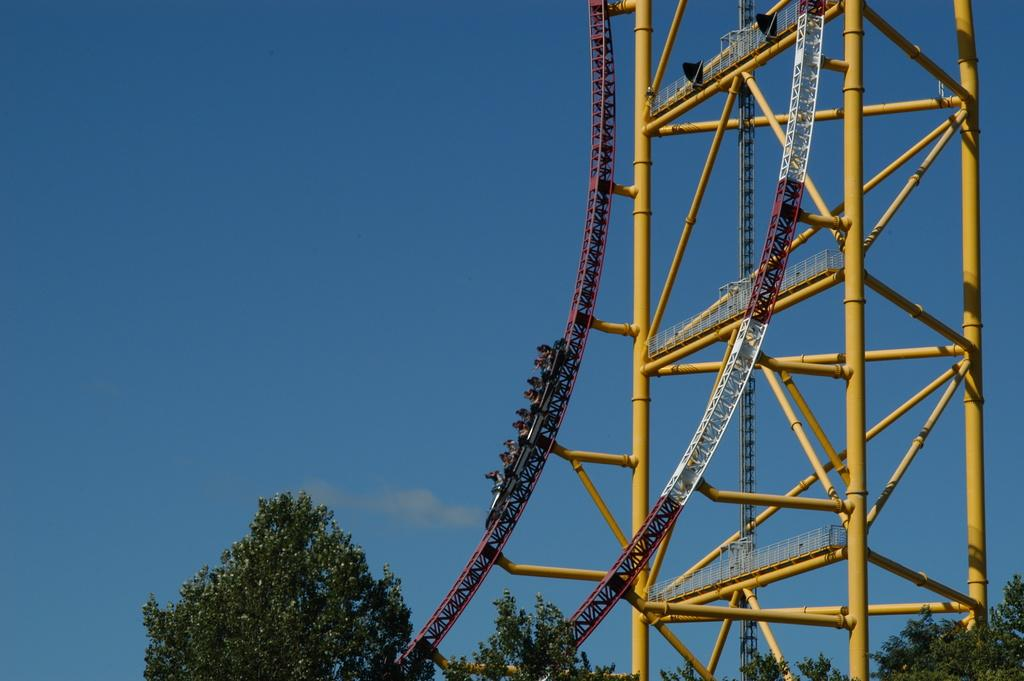What is the main subject of the image? The main subject of the image is a roller coaster. Are there any people in the image? Yes, there are persons in the image. What type of natural environment is visible at the bottom of the image? Trees are visible at the bottom of the image. What can be seen in the background of the image? The sky is visible in the background of the image. How many visitors are waiting in line for the cent in the image? There is no mention of a cent or visitors waiting in line in the image; it features a roller coaster and people. What type of parcel is being delivered to the roller coaster in the image? There is no parcel or delivery mentioned in the image; it only shows a roller coaster and people. 